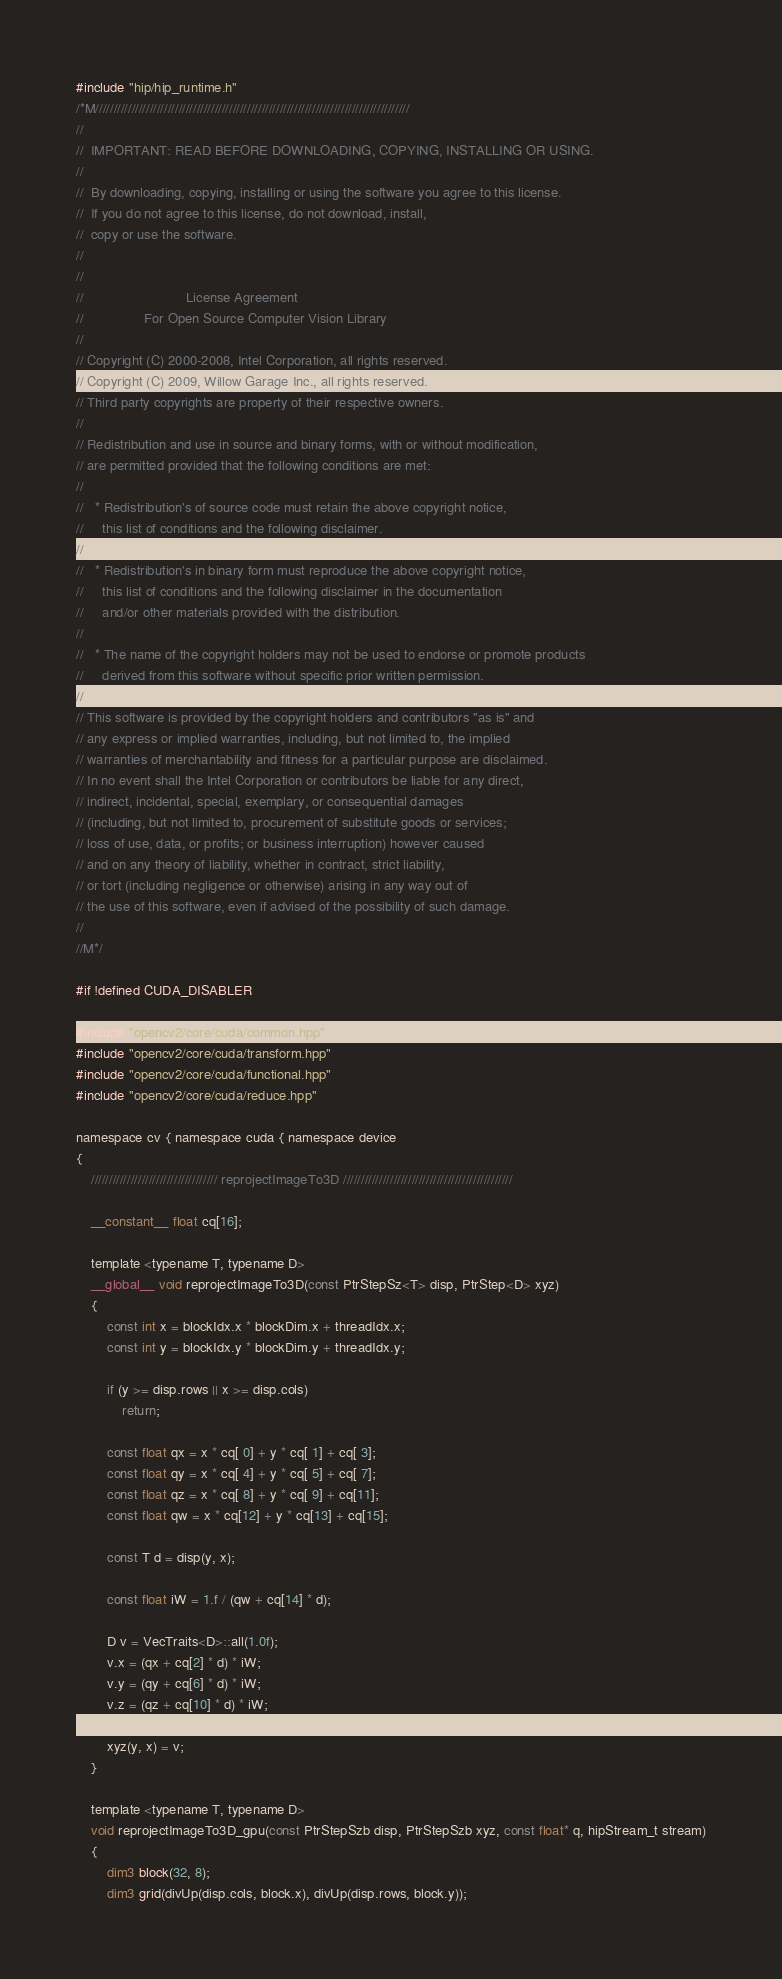Convert code to text. <code><loc_0><loc_0><loc_500><loc_500><_Cuda_>#include "hip/hip_runtime.h"
/*M///////////////////////////////////////////////////////////////////////////////////////
//
//  IMPORTANT: READ BEFORE DOWNLOADING, COPYING, INSTALLING OR USING.
//
//  By downloading, copying, installing or using the software you agree to this license.
//  If you do not agree to this license, do not download, install,
//  copy or use the software.
//
//
//                           License Agreement
//                For Open Source Computer Vision Library
//
// Copyright (C) 2000-2008, Intel Corporation, all rights reserved.
// Copyright (C) 2009, Willow Garage Inc., all rights reserved.
// Third party copyrights are property of their respective owners.
//
// Redistribution and use in source and binary forms, with or without modification,
// are permitted provided that the following conditions are met:
//
//   * Redistribution's of source code must retain the above copyright notice,
//     this list of conditions and the following disclaimer.
//
//   * Redistribution's in binary form must reproduce the above copyright notice,
//     this list of conditions and the following disclaimer in the documentation
//     and/or other materials provided with the distribution.
//
//   * The name of the copyright holders may not be used to endorse or promote products
//     derived from this software without specific prior written permission.
//
// This software is provided by the copyright holders and contributors "as is" and
// any express or implied warranties, including, but not limited to, the implied
// warranties of merchantability and fitness for a particular purpose are disclaimed.
// In no event shall the Intel Corporation or contributors be liable for any direct,
// indirect, incidental, special, exemplary, or consequential damages
// (including, but not limited to, procurement of substitute goods or services;
// loss of use, data, or profits; or business interruption) however caused
// and on any theory of liability, whether in contract, strict liability,
// or tort (including negligence or otherwise) arising in any way out of
// the use of this software, even if advised of the possibility of such damage.
//
//M*/

#if !defined CUDA_DISABLER

#include "opencv2/core/cuda/common.hpp"
#include "opencv2/core/cuda/transform.hpp"
#include "opencv2/core/cuda/functional.hpp"
#include "opencv2/core/cuda/reduce.hpp"

namespace cv { namespace cuda { namespace device
{
    /////////////////////////////////// reprojectImageTo3D ///////////////////////////////////////////////

    __constant__ float cq[16];

    template <typename T, typename D>
    __global__ void reprojectImageTo3D(const PtrStepSz<T> disp, PtrStep<D> xyz)
    {
        const int x = blockIdx.x * blockDim.x + threadIdx.x;
        const int y = blockIdx.y * blockDim.y + threadIdx.y;

        if (y >= disp.rows || x >= disp.cols)
            return;

        const float qx = x * cq[ 0] + y * cq[ 1] + cq[ 3];
        const float qy = x * cq[ 4] + y * cq[ 5] + cq[ 7];
        const float qz = x * cq[ 8] + y * cq[ 9] + cq[11];
        const float qw = x * cq[12] + y * cq[13] + cq[15];

        const T d = disp(y, x);

        const float iW = 1.f / (qw + cq[14] * d);

        D v = VecTraits<D>::all(1.0f);
        v.x = (qx + cq[2] * d) * iW;
        v.y = (qy + cq[6] * d) * iW;
        v.z = (qz + cq[10] * d) * iW;

        xyz(y, x) = v;
    }

    template <typename T, typename D>
    void reprojectImageTo3D_gpu(const PtrStepSzb disp, PtrStepSzb xyz, const float* q, hipStream_t stream)
    {
        dim3 block(32, 8);
        dim3 grid(divUp(disp.cols, block.x), divUp(disp.rows, block.y));
</code> 